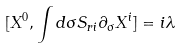Convert formula to latex. <formula><loc_0><loc_0><loc_500><loc_500>[ X ^ { 0 } , \int d \sigma S _ { r i } \partial _ { \sigma } X ^ { i } ] = i \lambda</formula> 